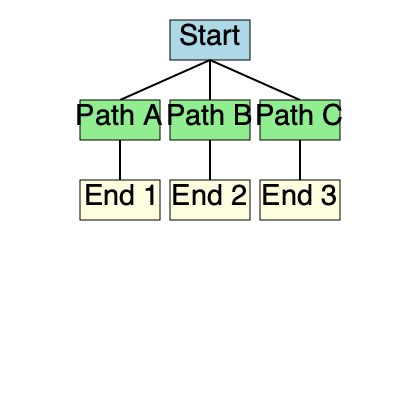Given the flowchart representing a narrative-driven game with multiple endings, calculate the replay value factor (RVF) using the formula: $RVF = \frac{E \times P}{T}$, where $E$ is the number of unique endings, $P$ is the number of distinct paths, and $T$ is the total number of possible playthroughs. What is the RVF for this game? To calculate the Replay Value Factor (RVF), we need to determine the values for E, P, and T:

1. Number of unique endings (E):
   There are 3 unique endings shown in the flowchart (End 1, End 2, and End 3).
   $E = 3$

2. Number of distinct paths (P):
   There are 3 distinct paths shown in the flowchart (Path A, Path B, and Path C).
   $P = 3$

3. Total number of possible playthroughs (T):
   Each path leads to a single ending, so the total number of playthroughs is equal to the number of paths.
   $T = 3$

Now, we can apply the formula:

$RVF = \frac{E \times P}{T}$

$RVF = \frac{3 \times 3}{3}$

$RVF = \frac{9}{3}$

$RVF = 3$

Therefore, the Replay Value Factor (RVF) for this game is 3.
Answer: 3 